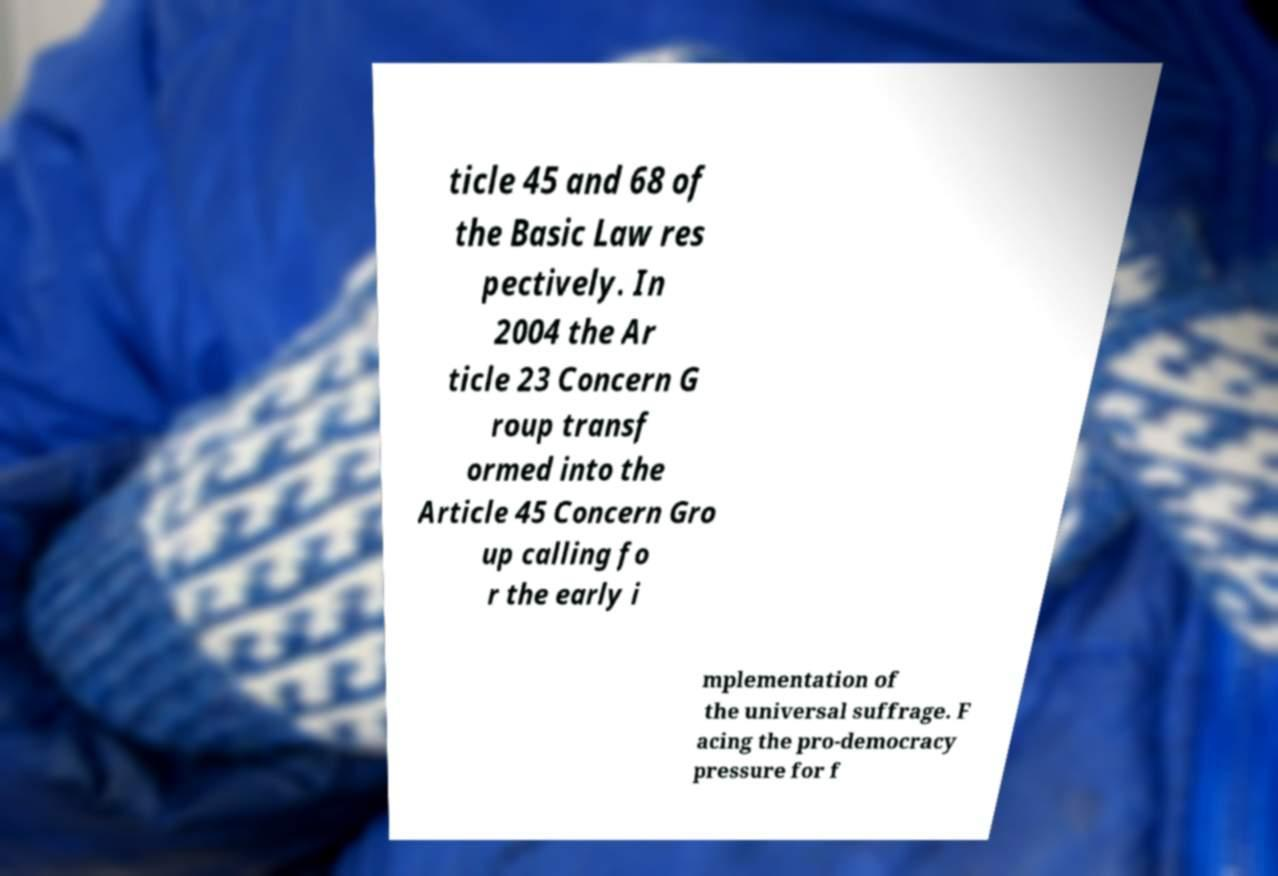Could you extract and type out the text from this image? ticle 45 and 68 of the Basic Law res pectively. In 2004 the Ar ticle 23 Concern G roup transf ormed into the Article 45 Concern Gro up calling fo r the early i mplementation of the universal suffrage. F acing the pro-democracy pressure for f 